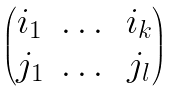<formula> <loc_0><loc_0><loc_500><loc_500>\begin{pmatrix} i _ { 1 } & \dots & i _ { k } \\ j _ { 1 } & \dots & j _ { l } \end{pmatrix}</formula> 